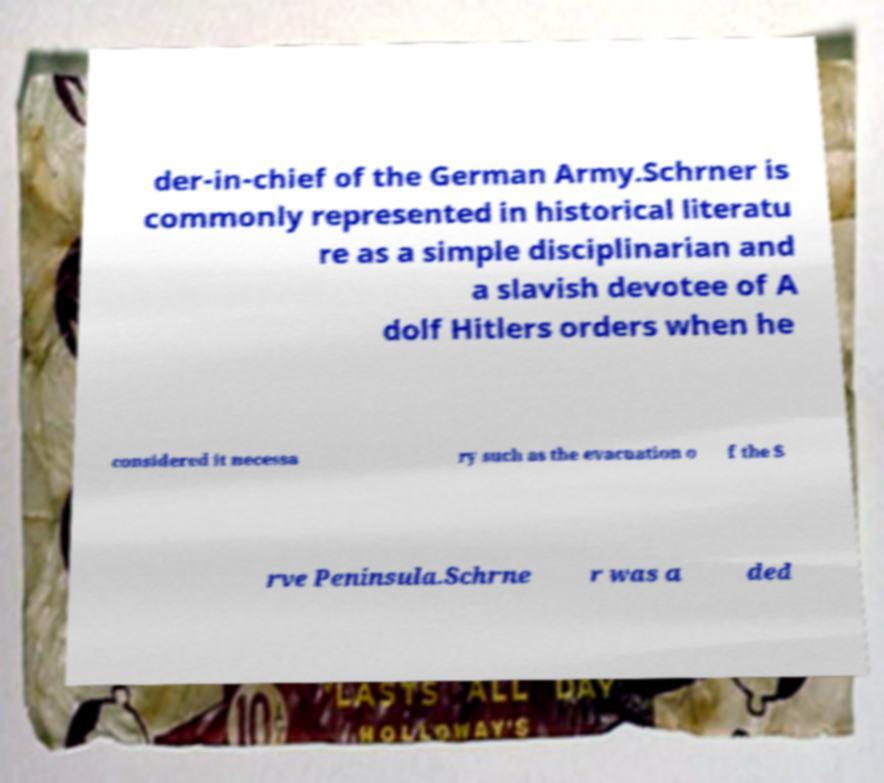Please identify and transcribe the text found in this image. der-in-chief of the German Army.Schrner is commonly represented in historical literatu re as a simple disciplinarian and a slavish devotee of A dolf Hitlers orders when he considered it necessa ry such as the evacuation o f the S rve Peninsula.Schrne r was a ded 